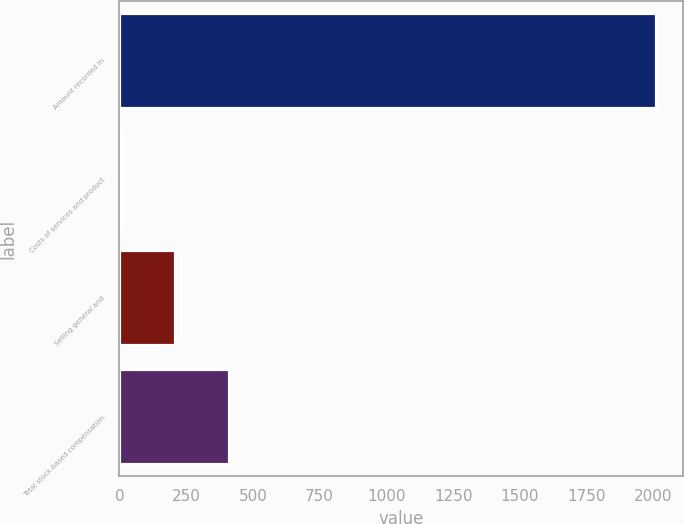<chart> <loc_0><loc_0><loc_500><loc_500><bar_chart><fcel>Amount recorded in<fcel>Costs of services and product<fcel>Selling general and<fcel>Total stock-based compensation<nl><fcel>2008<fcel>9.6<fcel>209.44<fcel>409.28<nl></chart> 